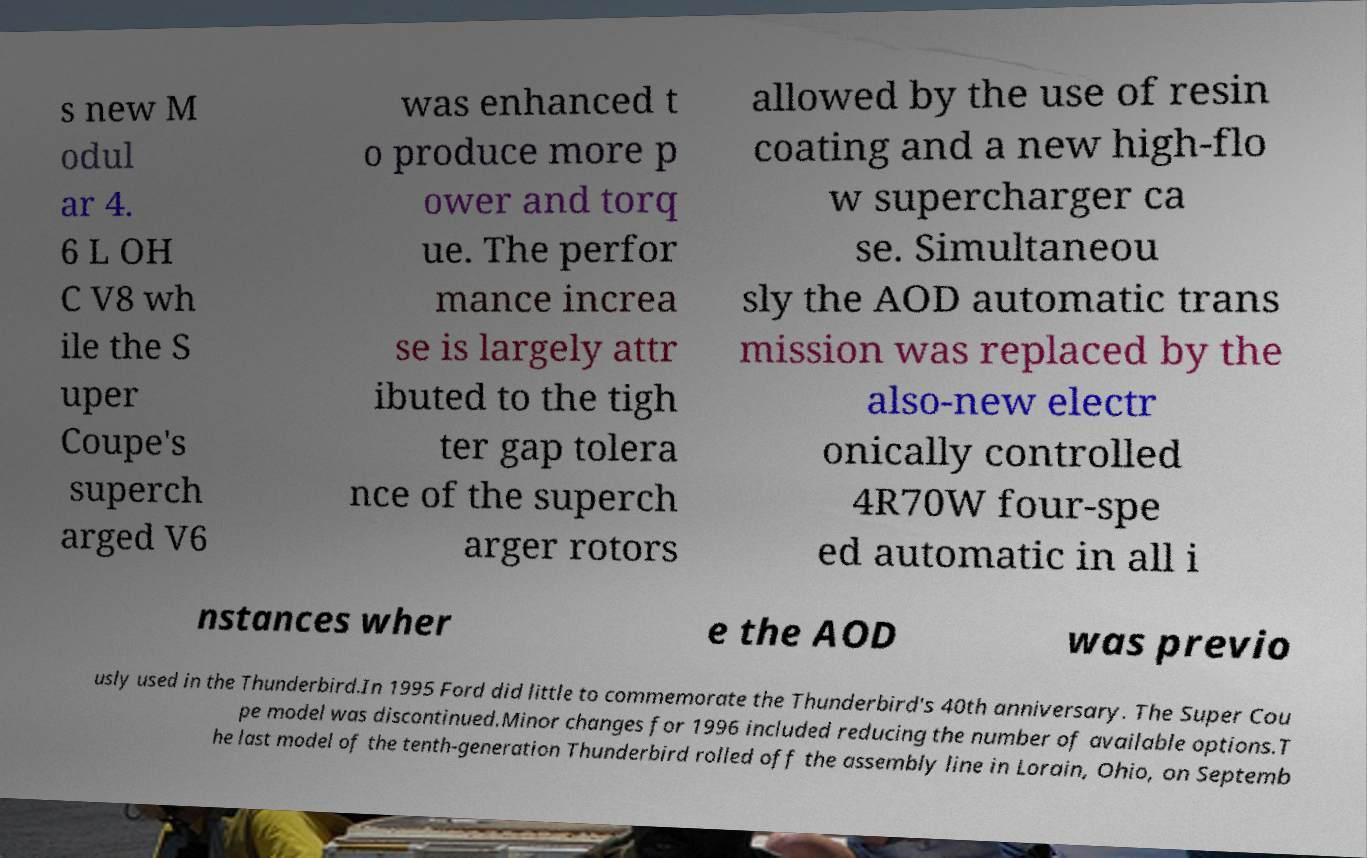Please read and relay the text visible in this image. What does it say? s new M odul ar 4. 6 L OH C V8 wh ile the S uper Coupe's superch arged V6 was enhanced t o produce more p ower and torq ue. The perfor mance increa se is largely attr ibuted to the tigh ter gap tolera nce of the superch arger rotors allowed by the use of resin coating and a new high-flo w supercharger ca se. Simultaneou sly the AOD automatic trans mission was replaced by the also-new electr onically controlled 4R70W four-spe ed automatic in all i nstances wher e the AOD was previo usly used in the Thunderbird.In 1995 Ford did little to commemorate the Thunderbird's 40th anniversary. The Super Cou pe model was discontinued.Minor changes for 1996 included reducing the number of available options.T he last model of the tenth-generation Thunderbird rolled off the assembly line in Lorain, Ohio, on Septemb 